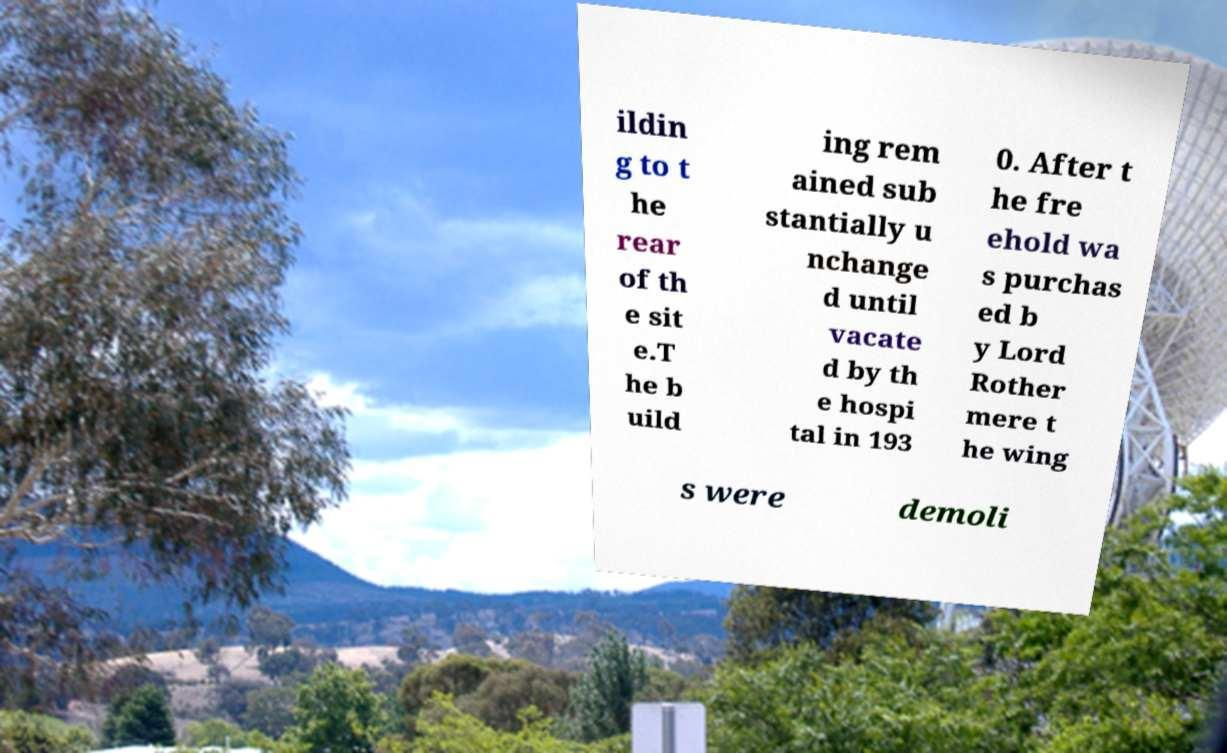I need the written content from this picture converted into text. Can you do that? ildin g to t he rear of th e sit e.T he b uild ing rem ained sub stantially u nchange d until vacate d by th e hospi tal in 193 0. After t he fre ehold wa s purchas ed b y Lord Rother mere t he wing s were demoli 